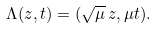<formula> <loc_0><loc_0><loc_500><loc_500>\Lambda ( z , t ) = ( \sqrt { \mu } \, z , \mu t ) .</formula> 